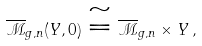<formula> <loc_0><loc_0><loc_500><loc_500>\overline { \mathcal { M } } _ { g , n } ( Y , 0 ) \cong \overline { \mathcal { M } } _ { g , n } \times Y \, ,</formula> 